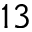<formula> <loc_0><loc_0><loc_500><loc_500>1 3</formula> 